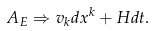Convert formula to latex. <formula><loc_0><loc_0><loc_500><loc_500>A _ { E } \Rightarrow v _ { k } d x ^ { k } + H d t .</formula> 